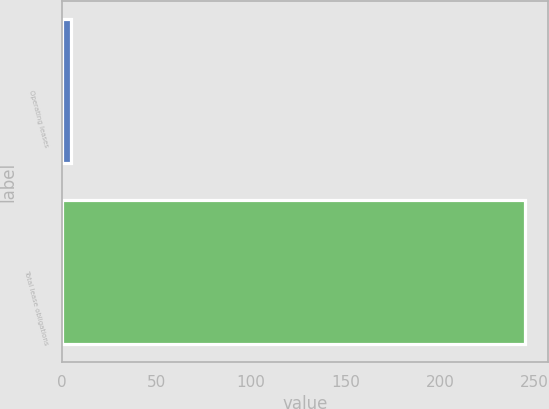Convert chart to OTSL. <chart><loc_0><loc_0><loc_500><loc_500><bar_chart><fcel>Operating leases<fcel>Total lease obligations<nl><fcel>5<fcel>245<nl></chart> 